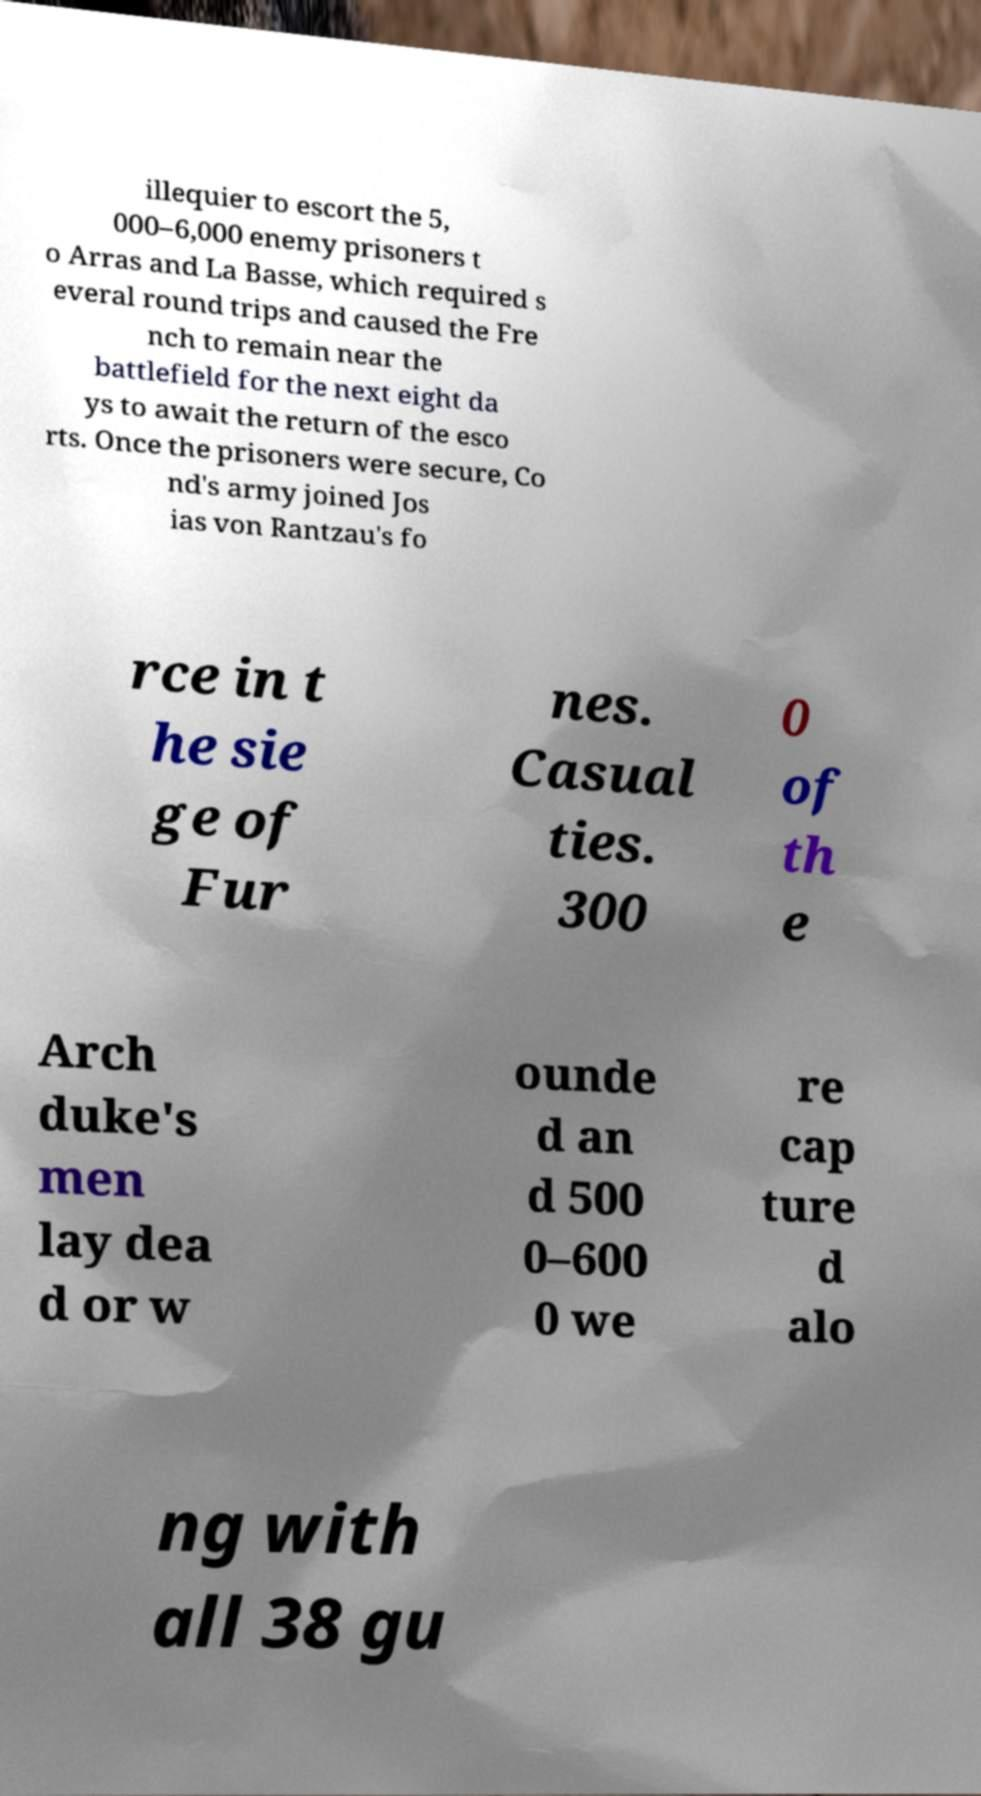Please read and relay the text visible in this image. What does it say? illequier to escort the 5, 000–6,000 enemy prisoners t o Arras and La Basse, which required s everal round trips and caused the Fre nch to remain near the battlefield for the next eight da ys to await the return of the esco rts. Once the prisoners were secure, Co nd's army joined Jos ias von Rantzau's fo rce in t he sie ge of Fur nes. Casual ties. 300 0 of th e Arch duke's men lay dea d or w ounde d an d 500 0–600 0 we re cap ture d alo ng with all 38 gu 